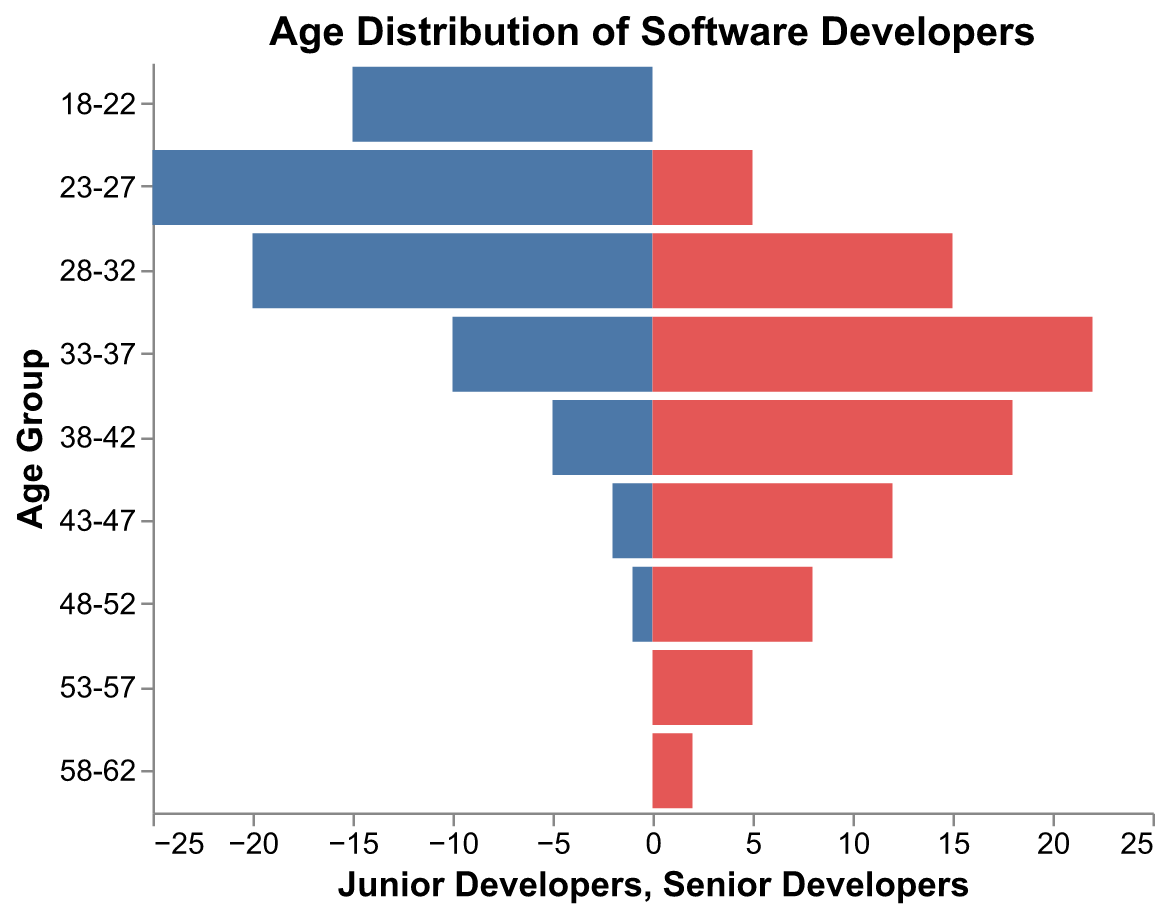What is the age group with the highest number of junior developers? The figure shows the number of junior developers for each age group. By looking at the bars representing junior developers, we observe that the age group 23-27 has the highest bar.
Answer: 23-27 Which age group has more senior developers, 33-37 or 38-42? By comparing the length of the bars for senior developers, the bar for age group 33-37 is longer than that for age group 38-42.
Answer: 33-37 How many senior developers are there in the age group 28-32? We find the bar for the senior developers in the age group 28-32. The number next to the bar indicates there are 15 senior developers.
Answer: 15 What is the total number of junior developers aged 23-32? Sum the number of junior developers in the age groups 23-27 and 28-32: 25 + 20 = 45.
Answer: 45 What is the difference in the number of developers between junior and senior in the age group 38-42? Subtract the number of junior developers from the number of senior developers in the age group 38-42: 18 - 5 = 13.
Answer: 13 Which age group has the greatest disparity between junior and senior developers? Calculate the differences for each age group and compare. The most significant difference is in the age group 33-37, with a disparity of 22 - 10 = 12.
Answer: 33-37 How many more senior developers are there in the age group 43-47 compared to the age group 48-52? Subtract the number of senior developers in the age group 48-52 from the number in the age group 43-47: 12 - 8 = 4.
Answer: 4 For the youngest and oldest age groups, how many senior developers are there in total? Add the number of senior developers in the youngest (18-22) and oldest (58-62) age groups: 0 + 2 = 2.
Answer: 2 What is the overall trend observed for the number of junior developers as age increases? Observe the pattern of the bars representing junior developers. The number of junior developers generally decreases as age increases.
Answer: Decreasing trend 